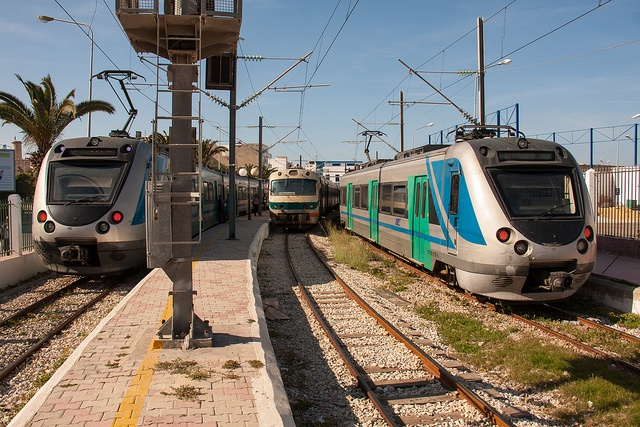Describe the objects in this image and their specific colors. I can see train in darkgray, black, gray, tan, and maroon tones, train in darkgray, black, and gray tones, train in darkgray, black, gray, and maroon tones, people in darkgray and black tones, and people in darkgray, black, maroon, and brown tones in this image. 